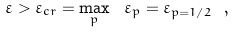<formula> <loc_0><loc_0><loc_500><loc_500>\varepsilon > \varepsilon _ { c r } = \max _ { p } \ \varepsilon _ { p } = \varepsilon _ { p = 1 / 2 } \ ,</formula> 